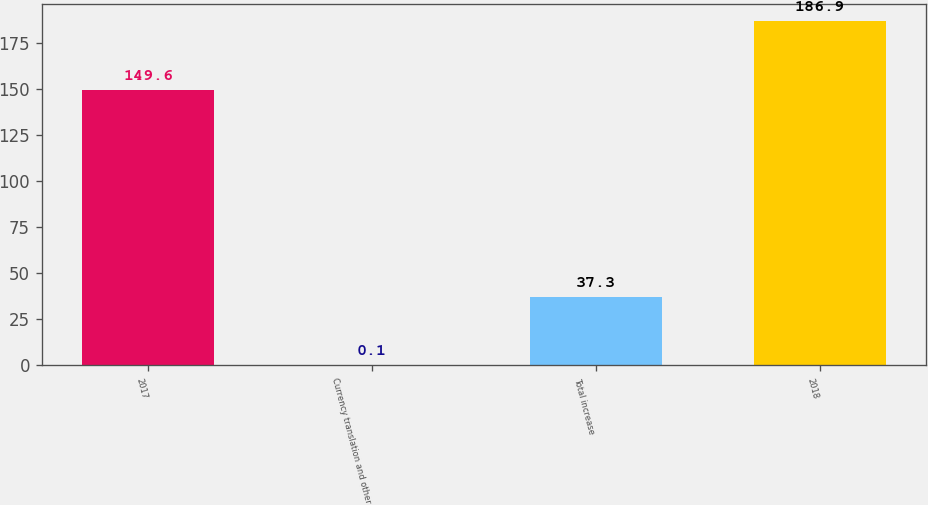Convert chart. <chart><loc_0><loc_0><loc_500><loc_500><bar_chart><fcel>2017<fcel>Currency translation and other<fcel>Total increase<fcel>2018<nl><fcel>149.6<fcel>0.1<fcel>37.3<fcel>186.9<nl></chart> 